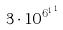Convert formula to latex. <formula><loc_0><loc_0><loc_500><loc_500>3 \cdot 1 0 ^ { { 6 ^ { 1 } } ^ { 1 } }</formula> 